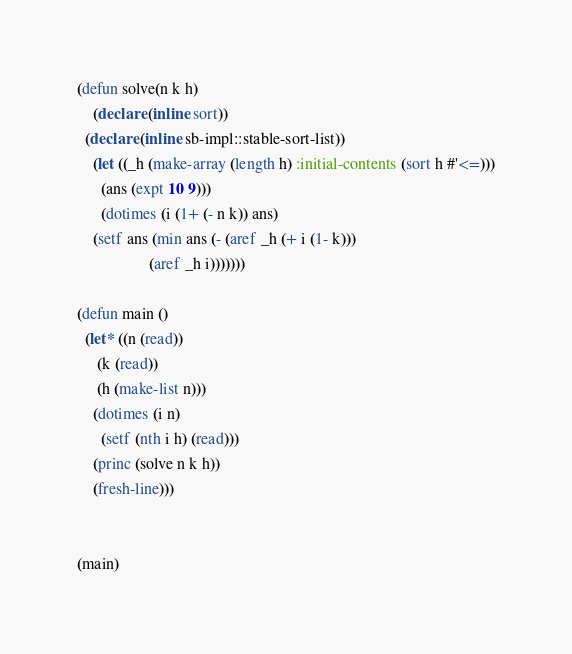<code> <loc_0><loc_0><loc_500><loc_500><_Lisp_>(defun solve(n k h)
    (declare (inline sort))
  (declare (inline sb-impl::stable-sort-list))
    (let ((_h (make-array (length h) :initial-contents (sort h #'<=)))
	  (ans (expt 10 9)))
      (dotimes (i (1+ (- n k)) ans)
	(setf ans (min ans (- (aref _h (+ i (1- k)))
			      (aref _h i)))))))

(defun main ()
  (let* ((n (read))
	 (k (read))
	 (h (make-list n)))
    (dotimes (i n)
      (setf (nth i h) (read)))
    (princ (solve n k h))
    (fresh-line)))


(main)
</code> 